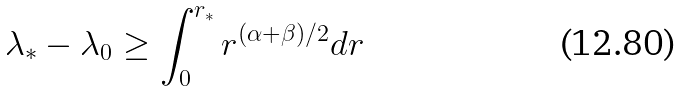<formula> <loc_0><loc_0><loc_500><loc_500>\lambda _ { * } - \lambda _ { 0 } \geq \int _ { 0 } ^ { r _ { * } } r ^ { ( \alpha + \beta ) / 2 } d r</formula> 